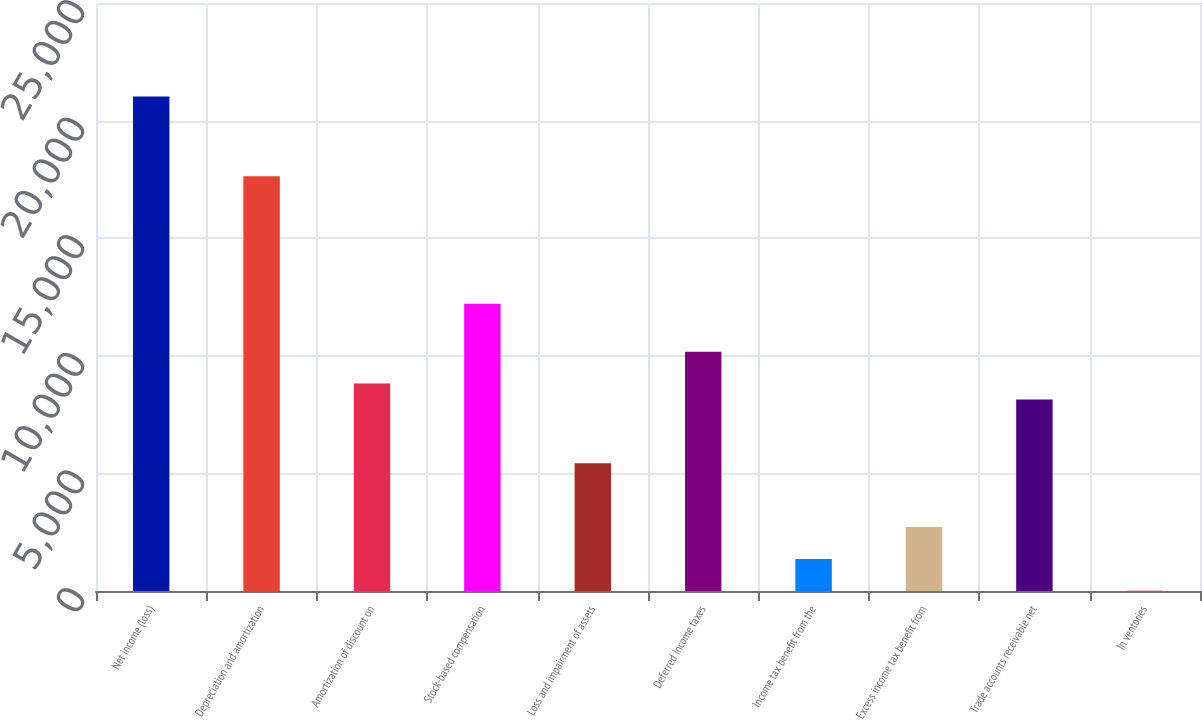<chart> <loc_0><loc_0><loc_500><loc_500><bar_chart><fcel>Net income (loss)<fcel>Depreciation and amortization<fcel>Amortization of discount on<fcel>Stock-based compensation<fcel>Loss and impairment of assets<fcel>Deferred income taxes<fcel>Income tax benefit from the<fcel>Excess income tax benefit from<fcel>Trade accounts receivable net<fcel>In ventories<nl><fcel>21024<fcel>17634<fcel>8820<fcel>12210<fcel>5430<fcel>10176<fcel>1362<fcel>2718<fcel>8142<fcel>6<nl></chart> 